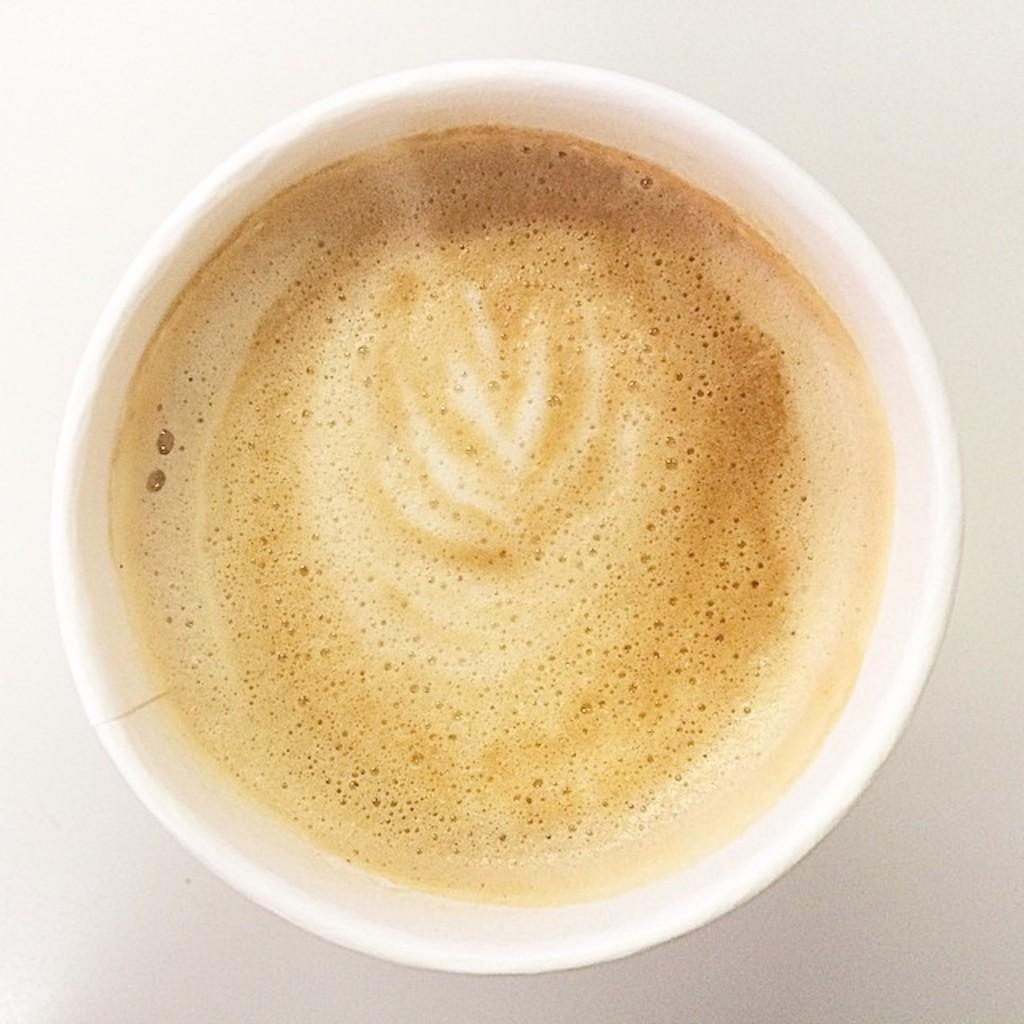What is in the cup that is visible in the image? There is coffee in the cup. What type of beverage is in the cup? The beverage in the cup is coffee. Where is the spot of jam on the cup in the image? There is no spot of jam on the cup in the image; it only contains coffee. 